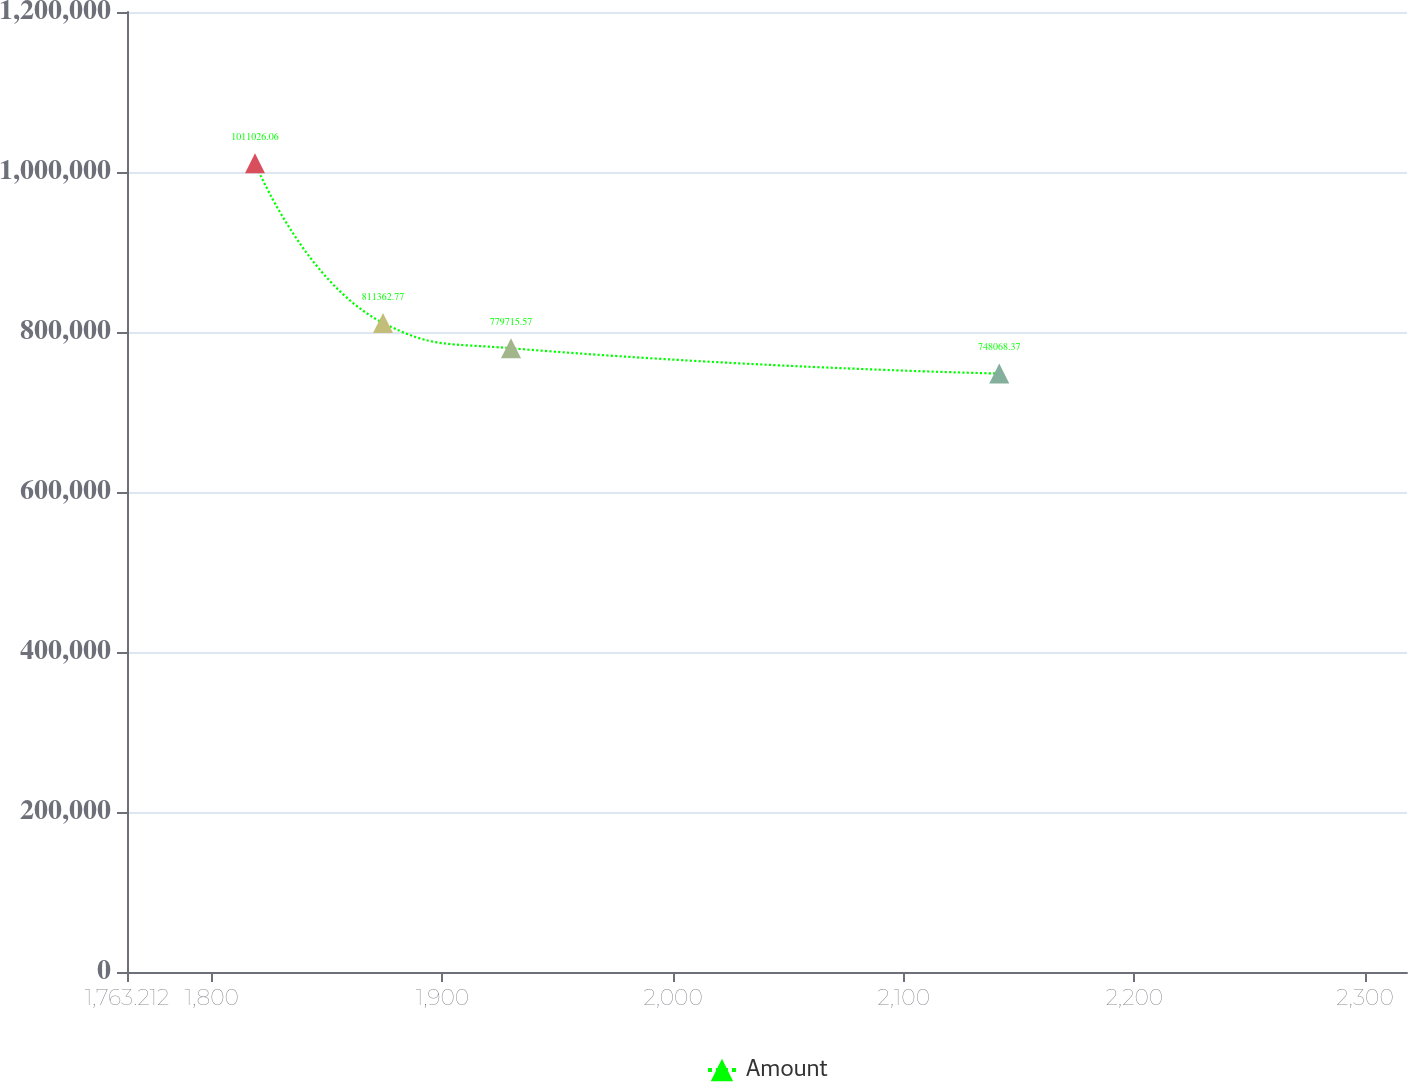Convert chart. <chart><loc_0><loc_0><loc_500><loc_500><line_chart><ecel><fcel>Amount<nl><fcel>1818.71<fcel>1.01103e+06<nl><fcel>1874.21<fcel>811363<nl><fcel>1929.71<fcel>779716<nl><fcel>2141.39<fcel>748068<nl><fcel>2373.69<fcel>694554<nl></chart> 